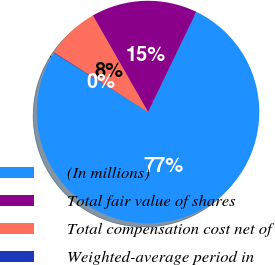Convert chart. <chart><loc_0><loc_0><loc_500><loc_500><pie_chart><fcel>(In millions)<fcel>Total fair value of shares<fcel>Total compensation cost net of<fcel>Weighted-average period in<nl><fcel>76.76%<fcel>15.41%<fcel>7.75%<fcel>0.08%<nl></chart> 